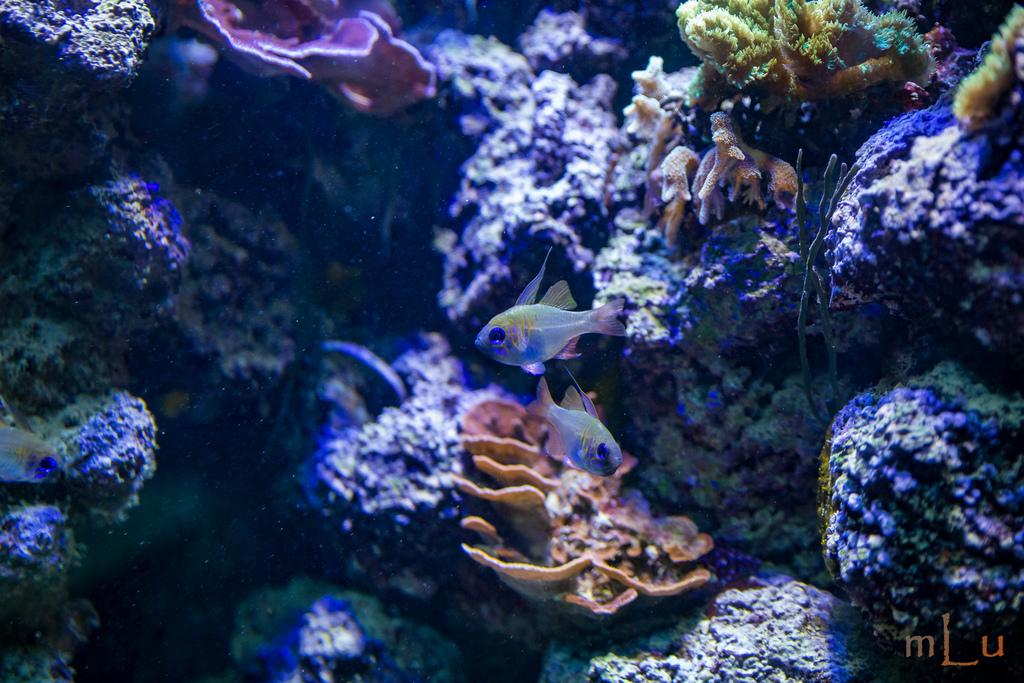What type of plants are visible in the image? There are water plants in the image. What other living organisms can be seen in the image? There are fishes in the water. Is there any text present in the image? Yes, there is some text in the bottom right corner of the image. What type of copper can be seen in the image? There is no copper present in the image. How many cans are visible in the image? There are no cans present in the image. 